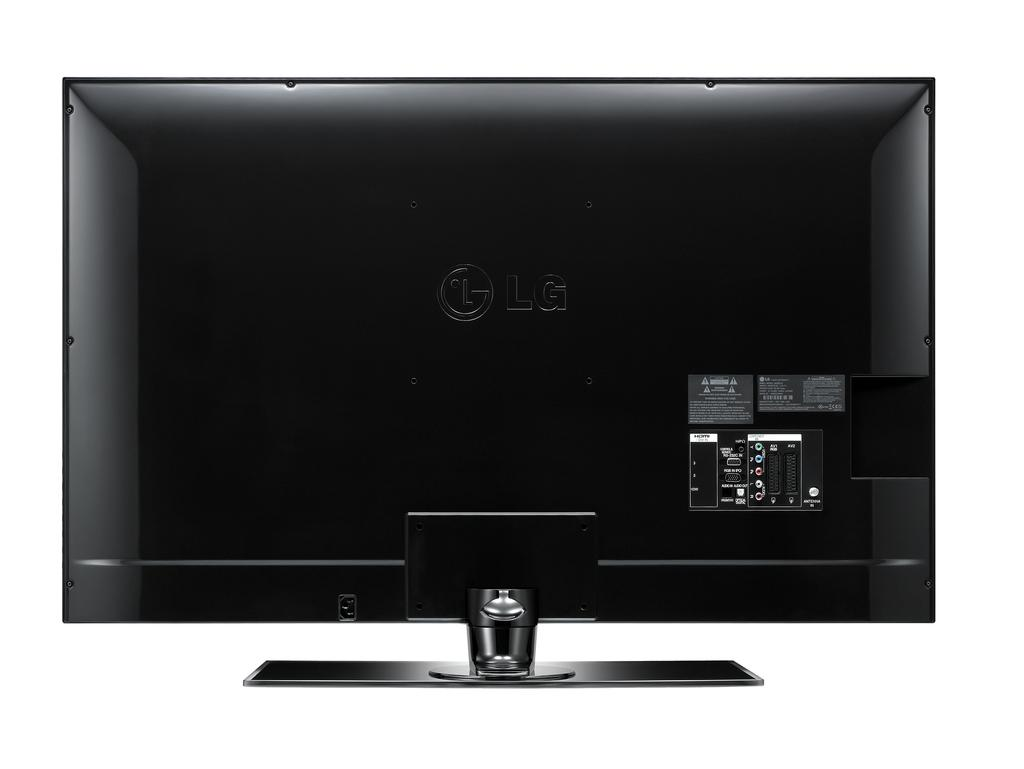<image>
Provide a brief description of the given image. The back side of an LG tv or computer monitor. 